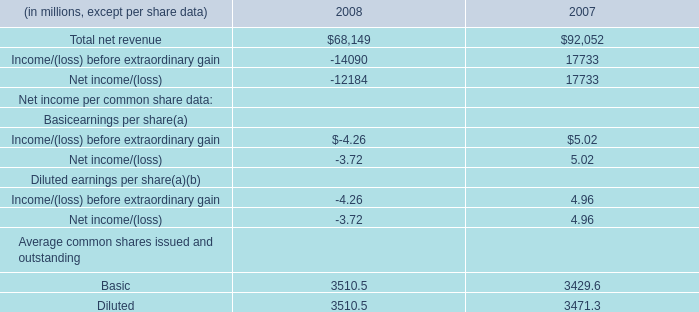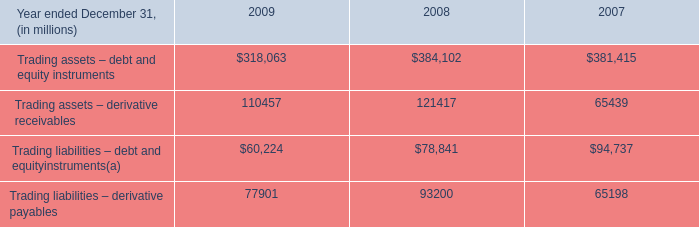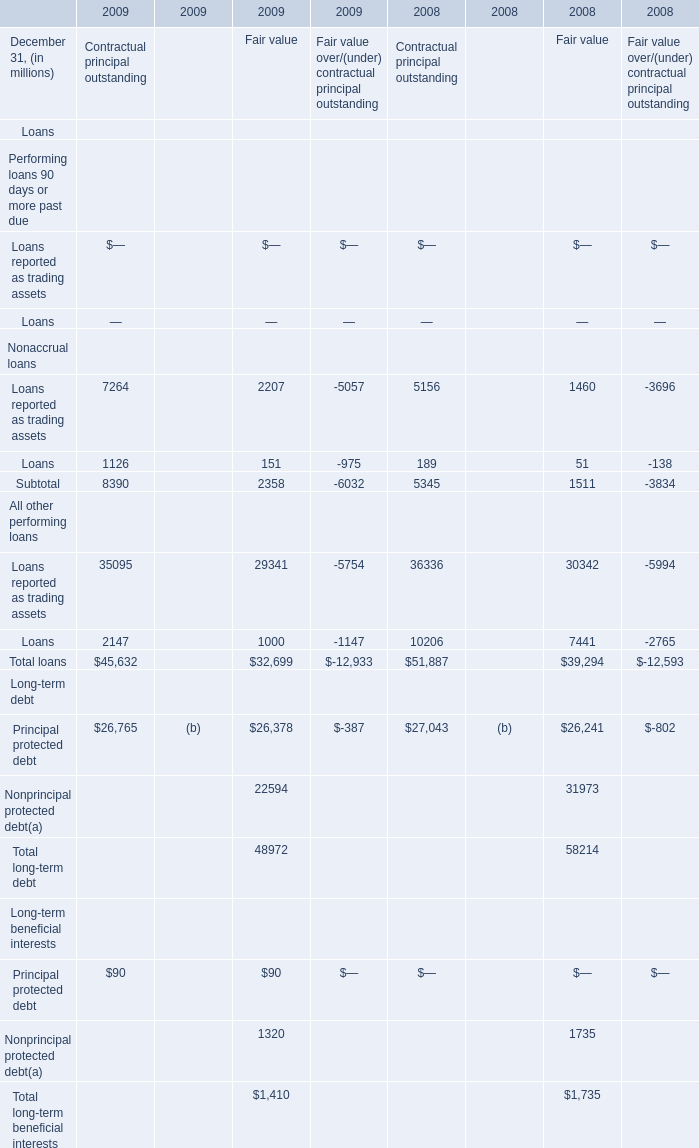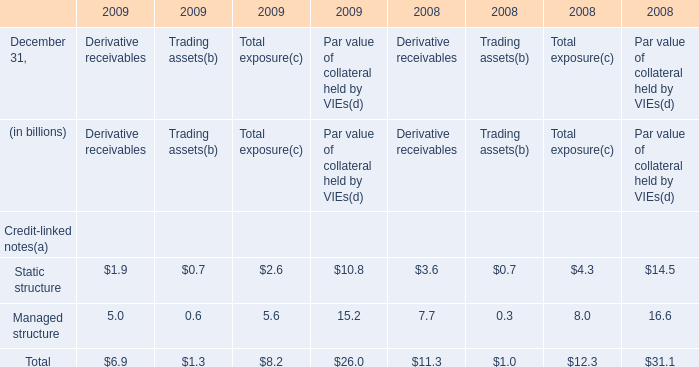In the year with largest amount of Basic for Average common shares issued and outstanding, what's the sum of Credit-linked notes(a) forTotal exposure(c)? (in billion) 
Computations: (4.3 + 8.0)
Answer: 12.3. 